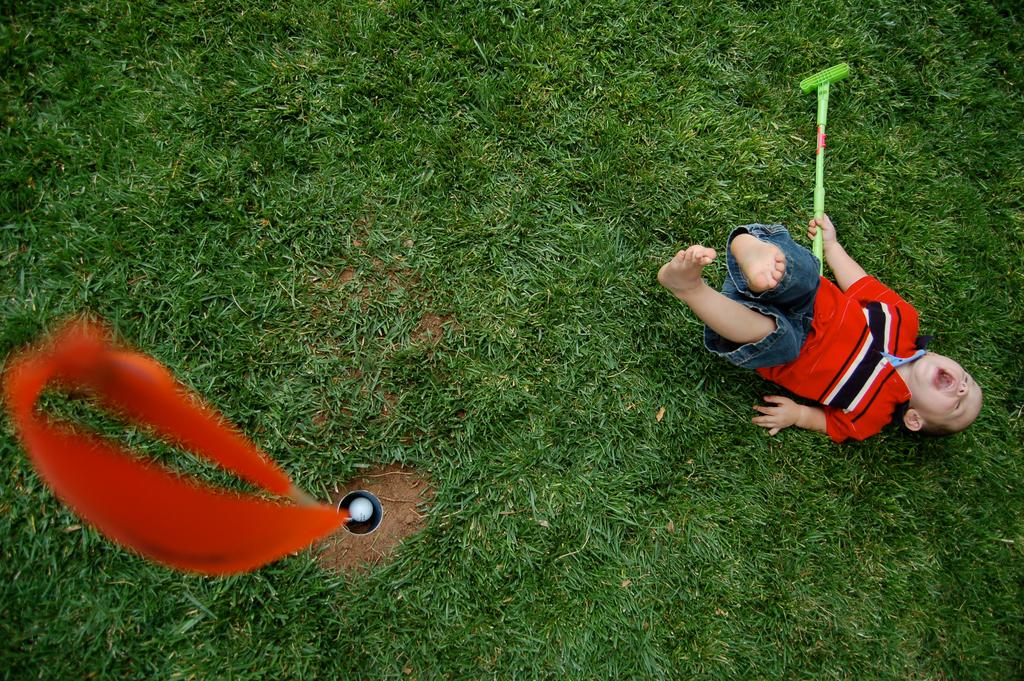What is the child doing in the image? The child is lying on the ground in the image. What is the child holding in his hand? The child is holding an object in his hand. Can you describe the pole with cloth in the image? There is a pole with cloth in the image. What other object can be seen in the image? There is a ball in the image. What type of surface is the child lying on? There is grass in the image, so the child is lying on the grass. What type of card is the robin holding in the image? There is no robin or card present in the image. How many blades of grass can be seen in the image? The number of blades of grass cannot be determined from the image, as it only shows a general area of grass. 